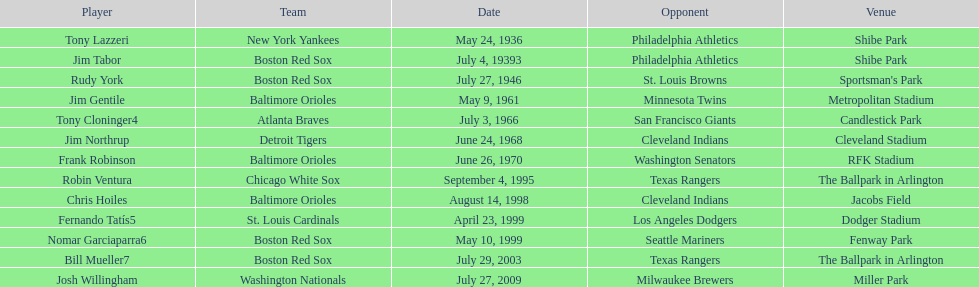Who are all the challengers? Philadelphia Athletics, Philadelphia Athletics, St. Louis Browns, Minnesota Twins, San Francisco Giants, Cleveland Indians, Washington Senators, Texas Rangers, Cleveland Indians, Los Angeles Dodgers, Seattle Mariners, Texas Rangers, Milwaukee Brewers. What teams took part on july 27, 1946? Boston Red Sox, July 27, 1946, St. Louis Browns. Who was the antagonist in this event? St. Louis Browns. 